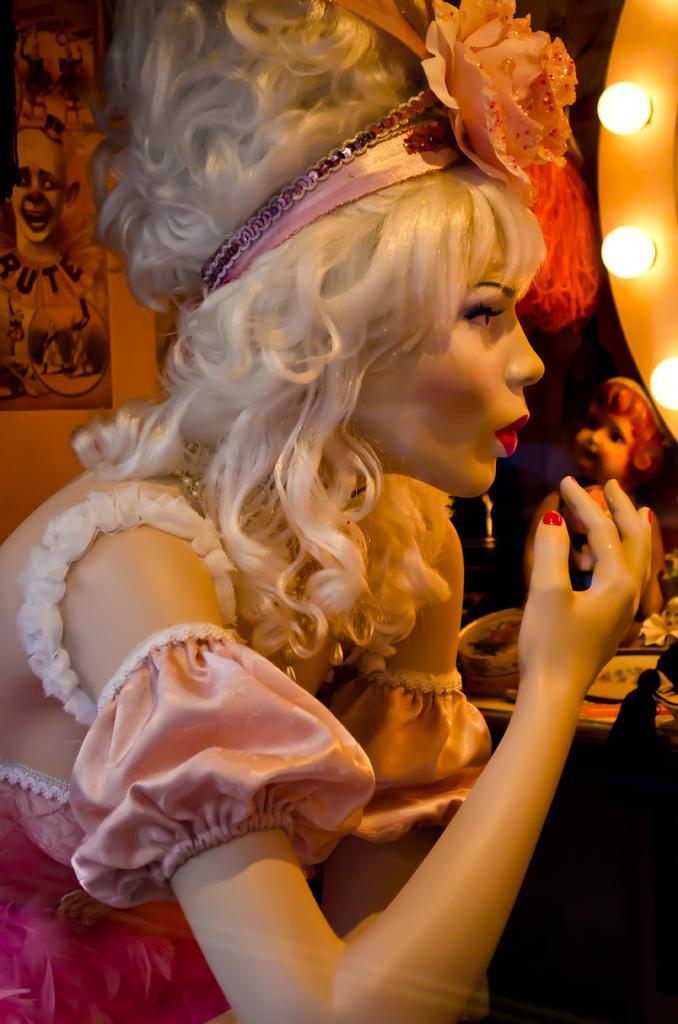Describe this image in one or two sentences. In this image there is a femme mannequin. There is a costume on the mannequin. In the top right there are bulbs. Beside the femme mannequin there is a table. On the table there are boxes and a doll. In the background there is a wall. There are posters sticked on the wall. There are images and text on the posters. 